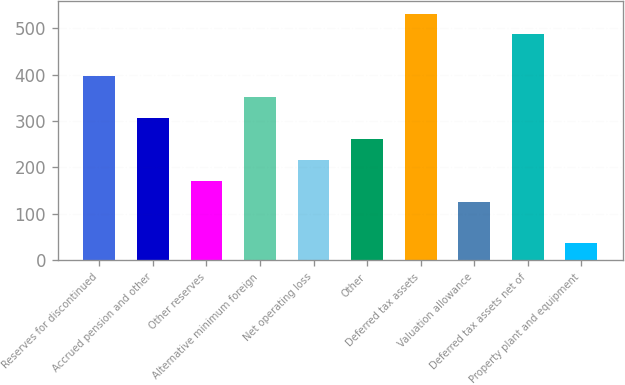Convert chart. <chart><loc_0><loc_0><loc_500><loc_500><bar_chart><fcel>Reserves for discontinued<fcel>Accrued pension and other<fcel>Other reserves<fcel>Alternative minimum foreign<fcel>Net operating loss<fcel>Other<fcel>Deferred tax assets<fcel>Valuation allowance<fcel>Deferred tax assets net of<fcel>Property plant and equipment<nl><fcel>396.84<fcel>306.68<fcel>171.44<fcel>351.76<fcel>216.52<fcel>261.6<fcel>532.08<fcel>126.36<fcel>487<fcel>36.2<nl></chart> 